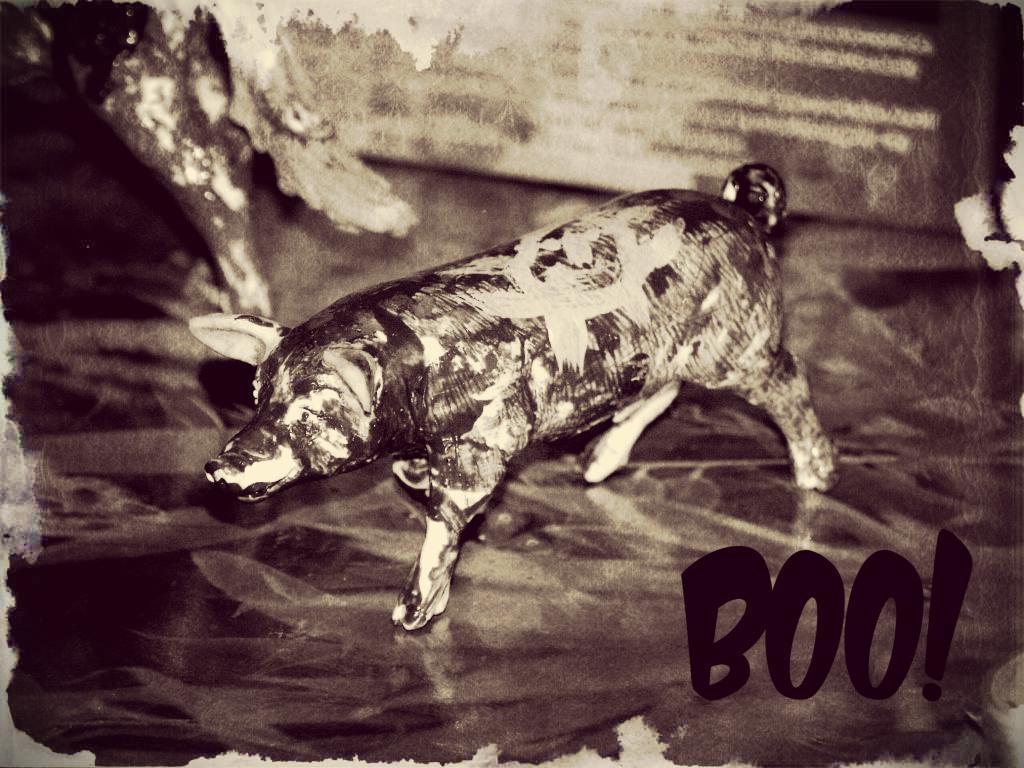In one or two sentences, can you explain what this image depicts? This is a image of the poster on which we can see there is a pig painting and text. 